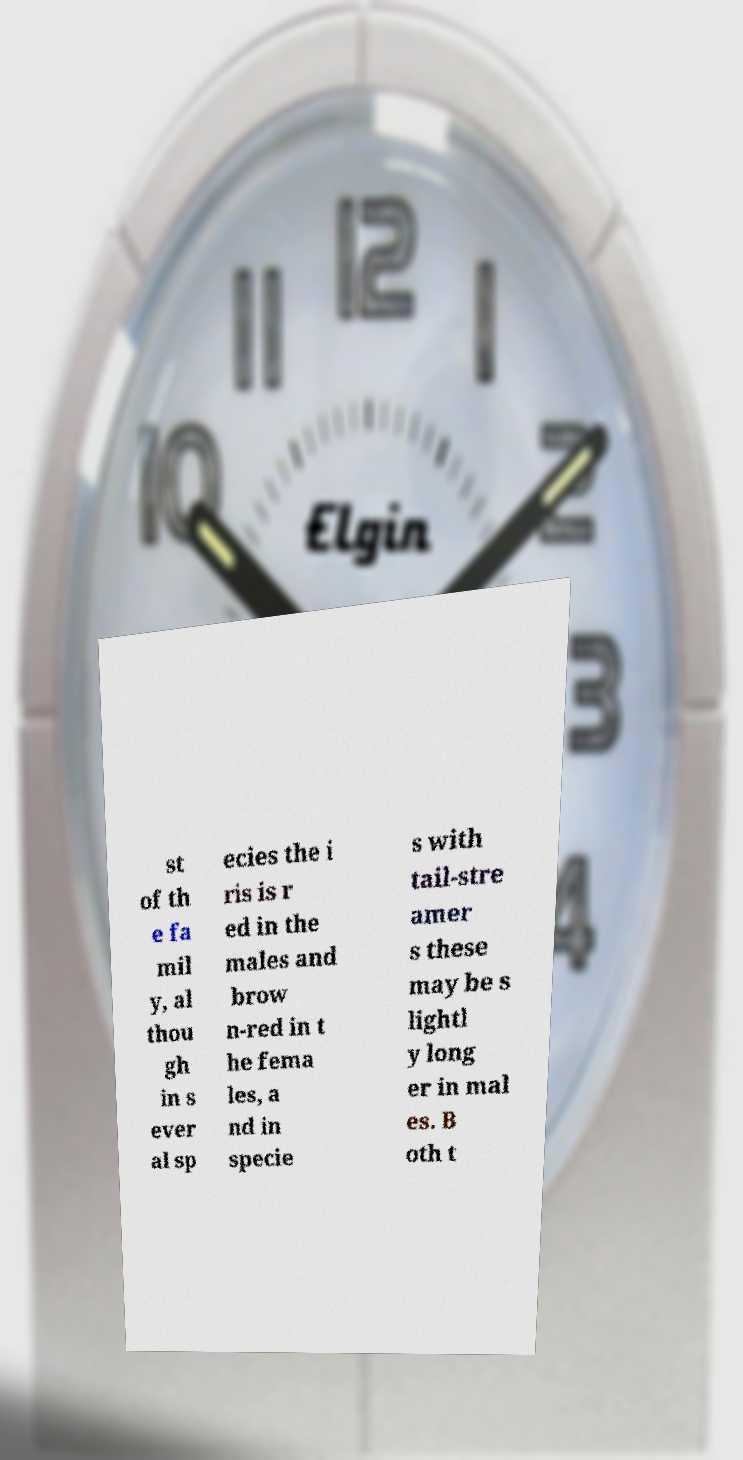Could you assist in decoding the text presented in this image and type it out clearly? st of th e fa mil y, al thou gh in s ever al sp ecies the i ris is r ed in the males and brow n-red in t he fema les, a nd in specie s with tail-stre amer s these may be s lightl y long er in mal es. B oth t 